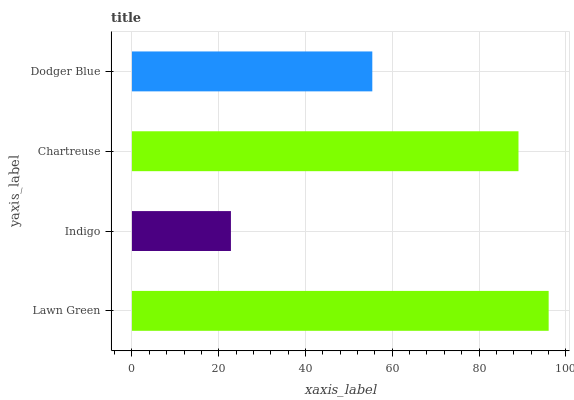Is Indigo the minimum?
Answer yes or no. Yes. Is Lawn Green the maximum?
Answer yes or no. Yes. Is Chartreuse the minimum?
Answer yes or no. No. Is Chartreuse the maximum?
Answer yes or no. No. Is Chartreuse greater than Indigo?
Answer yes or no. Yes. Is Indigo less than Chartreuse?
Answer yes or no. Yes. Is Indigo greater than Chartreuse?
Answer yes or no. No. Is Chartreuse less than Indigo?
Answer yes or no. No. Is Chartreuse the high median?
Answer yes or no. Yes. Is Dodger Blue the low median?
Answer yes or no. Yes. Is Indigo the high median?
Answer yes or no. No. Is Chartreuse the low median?
Answer yes or no. No. 